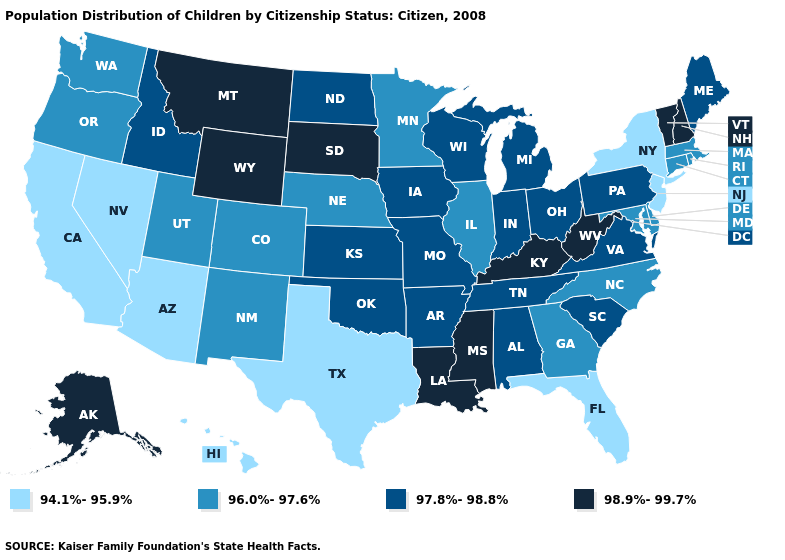What is the lowest value in the USA?
Quick response, please. 94.1%-95.9%. Does the first symbol in the legend represent the smallest category?
Answer briefly. Yes. What is the value of Mississippi?
Answer briefly. 98.9%-99.7%. Does California have the lowest value in the USA?
Answer briefly. Yes. What is the value of Maryland?
Quick response, please. 96.0%-97.6%. What is the value of Tennessee?
Write a very short answer. 97.8%-98.8%. What is the value of Ohio?
Be succinct. 97.8%-98.8%. Does the map have missing data?
Give a very brief answer. No. Name the states that have a value in the range 96.0%-97.6%?
Concise answer only. Colorado, Connecticut, Delaware, Georgia, Illinois, Maryland, Massachusetts, Minnesota, Nebraska, New Mexico, North Carolina, Oregon, Rhode Island, Utah, Washington. What is the value of Massachusetts?
Write a very short answer. 96.0%-97.6%. Does Illinois have the lowest value in the MidWest?
Keep it brief. Yes. What is the value of Maine?
Write a very short answer. 97.8%-98.8%. What is the value of Vermont?
Concise answer only. 98.9%-99.7%. Which states hav the highest value in the South?
Write a very short answer. Kentucky, Louisiana, Mississippi, West Virginia. 